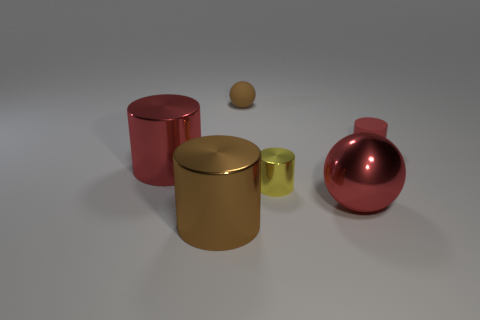What is the color of the other big thing that is the same shape as the brown rubber object? red 